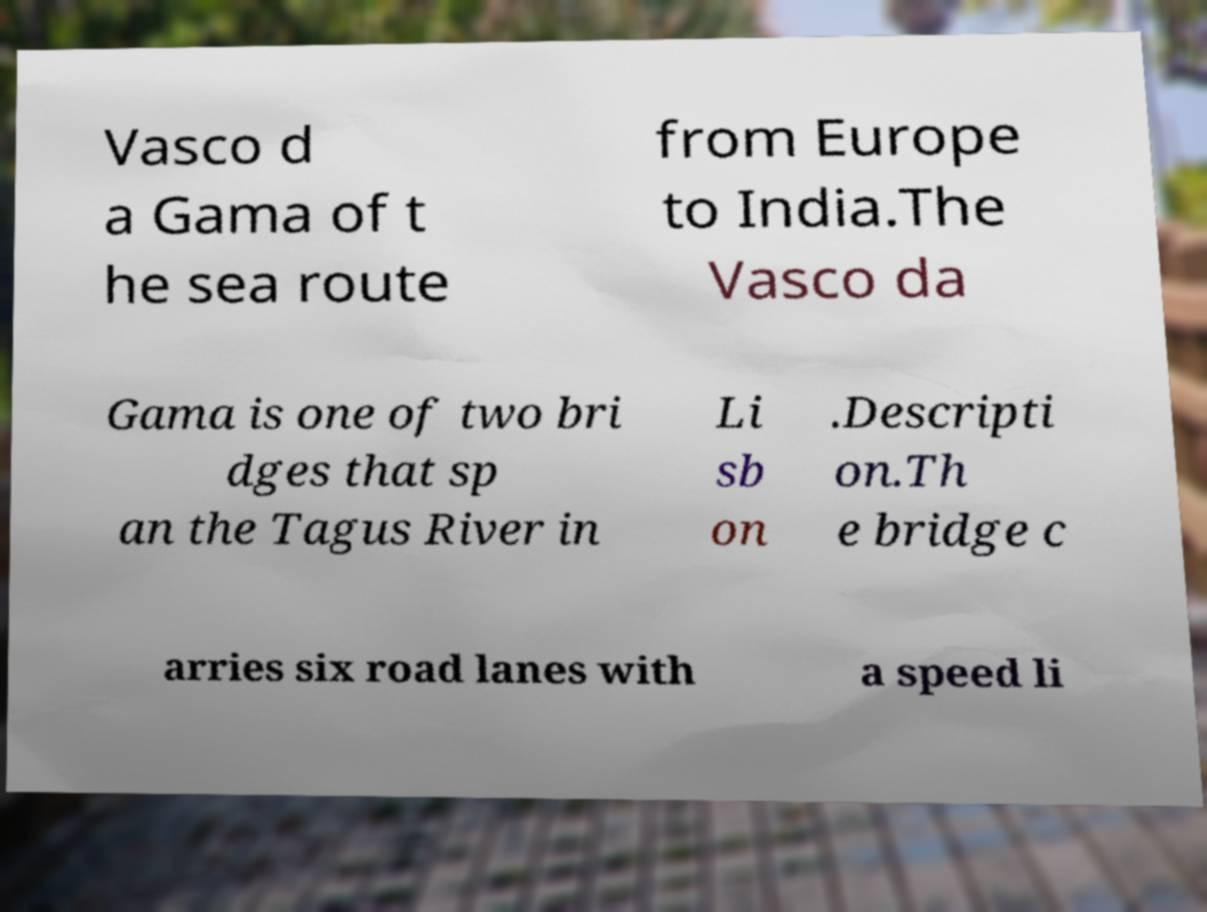I need the written content from this picture converted into text. Can you do that? Vasco d a Gama of t he sea route from Europe to India.The Vasco da Gama is one of two bri dges that sp an the Tagus River in Li sb on .Descripti on.Th e bridge c arries six road lanes with a speed li 